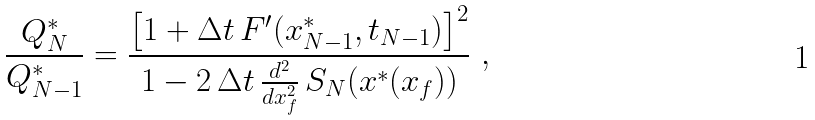Convert formula to latex. <formula><loc_0><loc_0><loc_500><loc_500>\frac { Q ^ { \ast } _ { N } } { Q ^ { \ast } _ { N - 1 } } = \frac { \left [ 1 + \Delta t \, F ^ { \prime } ( x ^ { \ast } _ { N - 1 } , t _ { N - 1 } ) \right ] ^ { 2 } } { 1 - 2 \, \Delta t \, \frac { d ^ { 2 } } { d x _ { f } ^ { 2 } } \, S _ { N } ( { x } ^ { \ast } ( x _ { f } ) ) } \ ,</formula> 